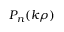<formula> <loc_0><loc_0><loc_500><loc_500>P _ { n } ( k \rho )</formula> 